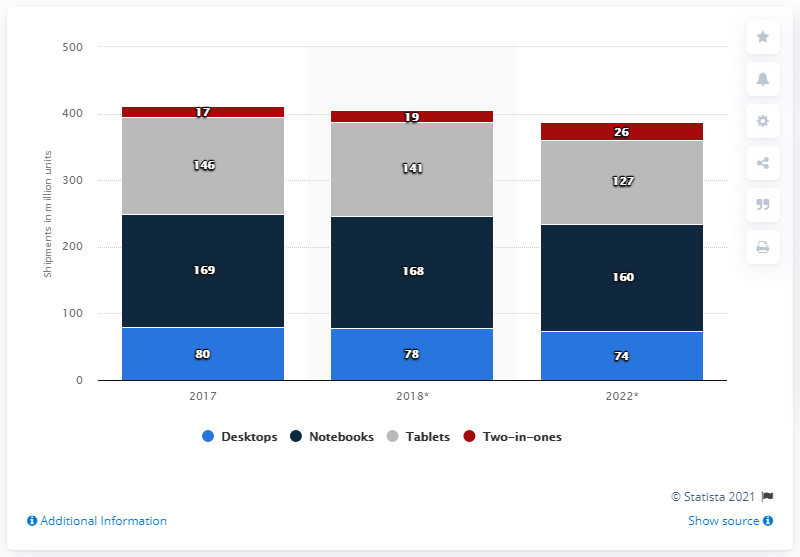Mention a couple of crucial points in this snapshot. It is estimated that 127 million tablets will be shipped worldwide in 2022. 